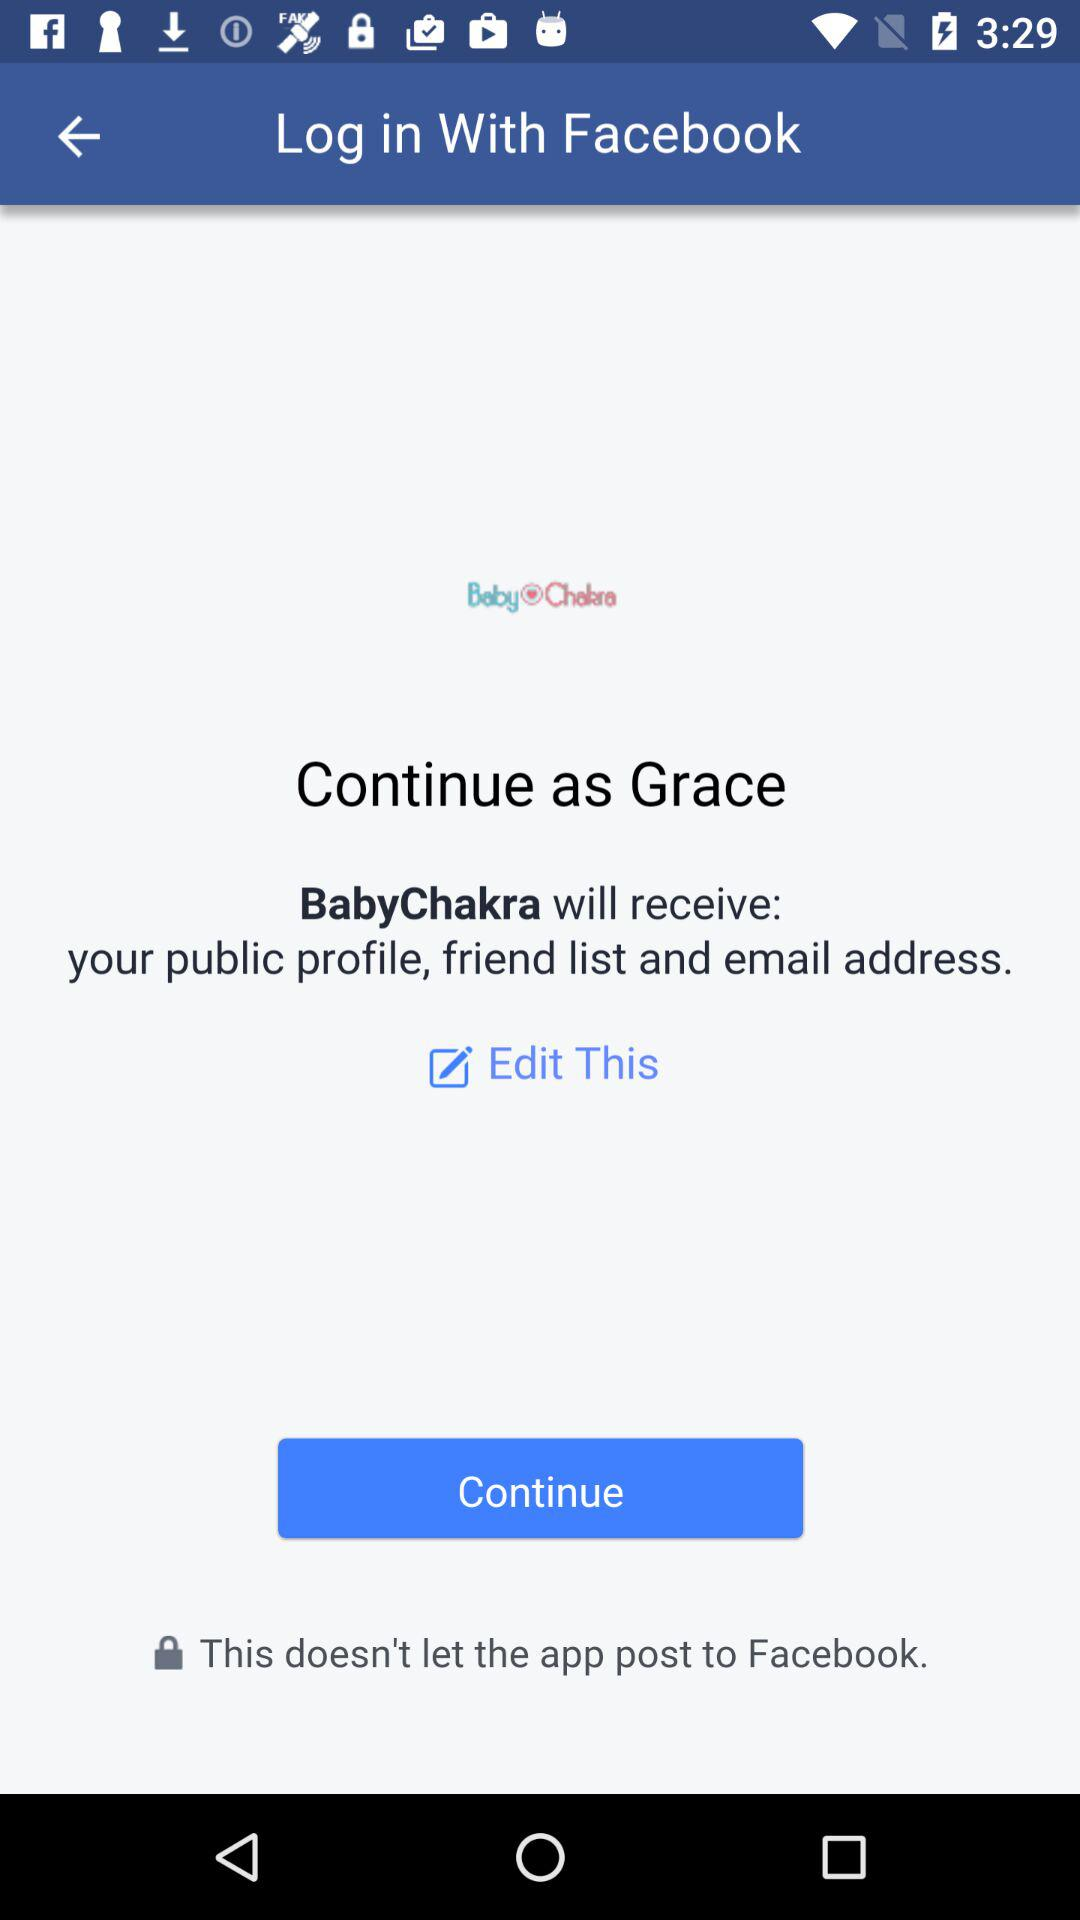What is the name of the user? The name of the user is Grace. 